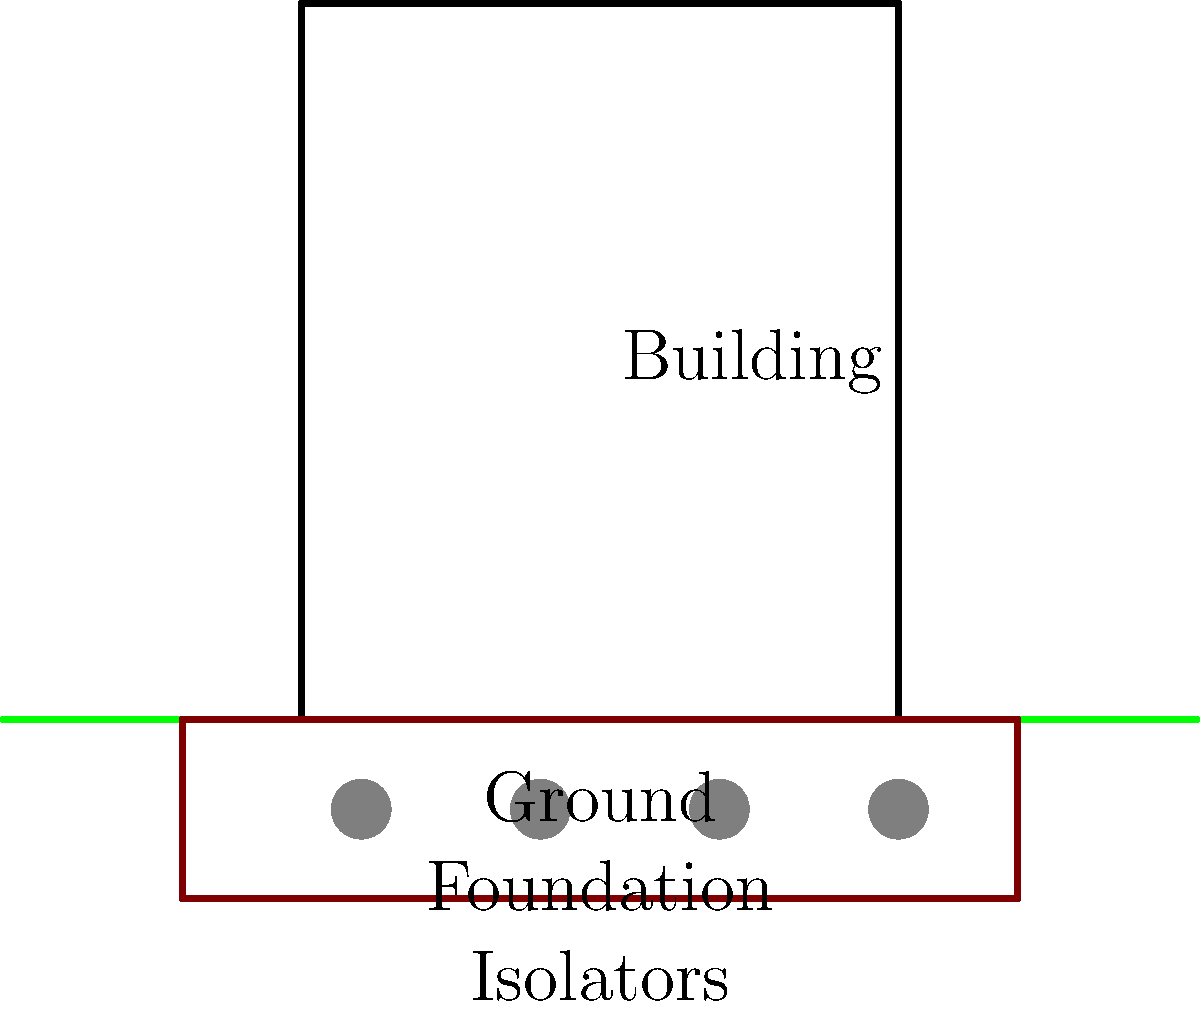As an expert in earthquake-resistant design for religious buildings, you are tasked with explaining the concept of base isolation. How does this system work to protect structures during seismic events, and what are the key components involved in its implementation? To understand base isolation for earthquake-resistant foundations, let's break it down step-by-step:

1. Concept: Base isolation is a technique used to protect buildings from earthquake damage by essentially decoupling the structure from the ground.

2. Key Components:
   a) Isolators: These are flexible bearings placed between the foundation and the superstructure.
   b) Foundation: A rigid platform that sits on top of the isolators.
   c) Superstructure: The main building structure above the foundation.

3. Working Principle:
   a) During an earthquake, the ground moves horizontally.
   b) The isolators allow the foundation to move relatively independently from the ground.
   c) This movement absorbs much of the seismic energy, reducing the forces transmitted to the superstructure.

4. Types of Isolators:
   a) Elastomeric bearings: Made of rubber and steel layers.
   b) Friction pendulum bearings: Use friction and gravity to dissipate energy.

5. Mathematical Representation:
   The period of an isolated structure is given by:
   $$T = 2\pi \sqrt{\frac{m}{k}}$$
   Where $m$ is the mass of the structure and $k$ is the stiffness of the isolation system.

6. Benefits:
   a) Reduces lateral forces on the structure by factor of 2 to 5.
   b) Decreases acceleration experienced by building occupants.
   c) Minimizes damage to building contents and structural elements.

7. Considerations for Religious Buildings:
   a) Preserving architectural integrity while implementing modern technology.
   b) Ensuring the system can support heavy masonry or ornate structures common in religious buildings.
   c) Designing for long-term durability to protect historical and cultural significance.

8. Implementation:
   a) Conduct site-specific seismic hazard analysis.
   b) Design isolators based on building weight and expected ground motion.
   c) Create a rigid foundation to distribute loads evenly.
   d) Install isolators between the foundation and superstructure.
   e) Provide flexible connections for utilities to accommodate movement.

By implementing base isolation, religious buildings can be protected from seismic damage while preserving their spiritual and cultural importance for the community.
Answer: Base isolation decouples the building from ground motion using flexible bearings (isolators) between the foundation and superstructure, reducing seismic forces transmitted to the building. 